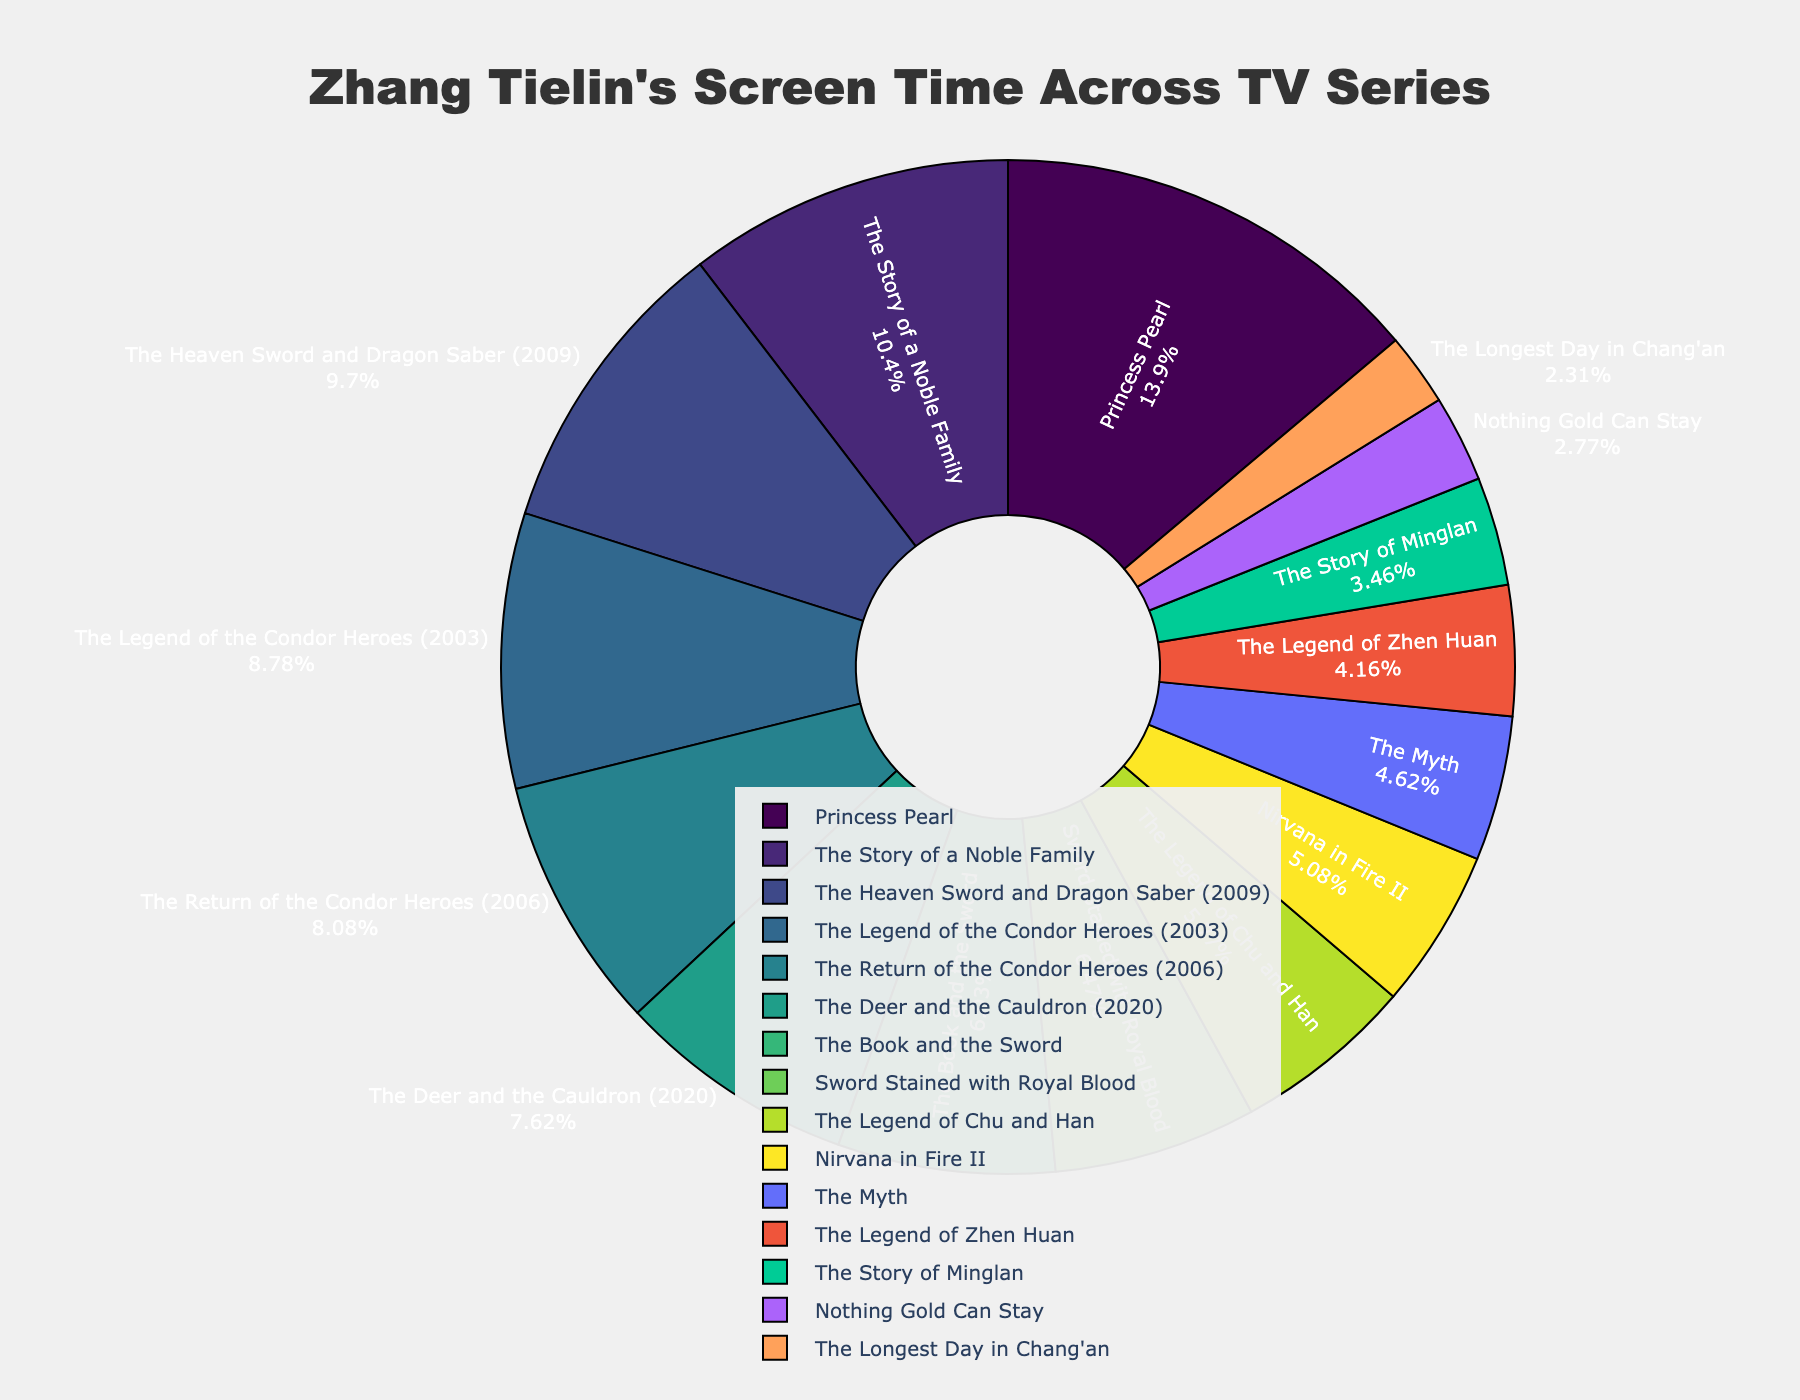What series has the highest share of Zhang Tielin's screen time? The series with the largest portion of the pie chart represents the highest screen time. By inspecting the pie chart, we see that "Princess Pearl" has the biggest slice.
Answer: Princess Pearl Which two series combined account for more screen time than The Heaven Sword and Dragon Saber (2009)? Find The Heaven Sword and Dragon Saber (2009) and note its screen time percentage. Then, identify combinations of other series' percentages that collectively exceed this value. "Princess Pearl" and "The Story of a Noble Family" combined have more screen time.
Answer: Princess Pearl and The Story of a Noble Family What series has the smallest share of Zhang Tielin's screen time? The series with the smallest slice of the pie chart represents the smallest screen time. By inspecting the pie chart, we find that "The Longest Day in Chang'an" has the smallest slice.
Answer: The Longest Day in Chang'an How much more screen time does Princess Pearl have compared to The Heaven Sword and Dragon Saber (2009)? Compare slices representing "Princess Pearl" and "The Heaven Sword and Dragon Saber (2009)" to see the difference in screen time percentages. Princess Pearl has a significantly larger slice. Princess Pearl has 60 hours and The Heaven Sword and Dragon Saber (2009) has 42 hours. Thus, the difference is 60 - 42 = 18 hours.
Answer: 18 hours What is the total screen time for the top three series in the chart? Identify and sum up the screen time of the top three series by the size of their slices: "Princess Pearl," "The Story of a Noble Family," and "The Heaven Sword and Dragon Saber (2009)". Adding their screen times, we get 60 + 45 + 42 = 147 hours.
Answer: 147 hours 